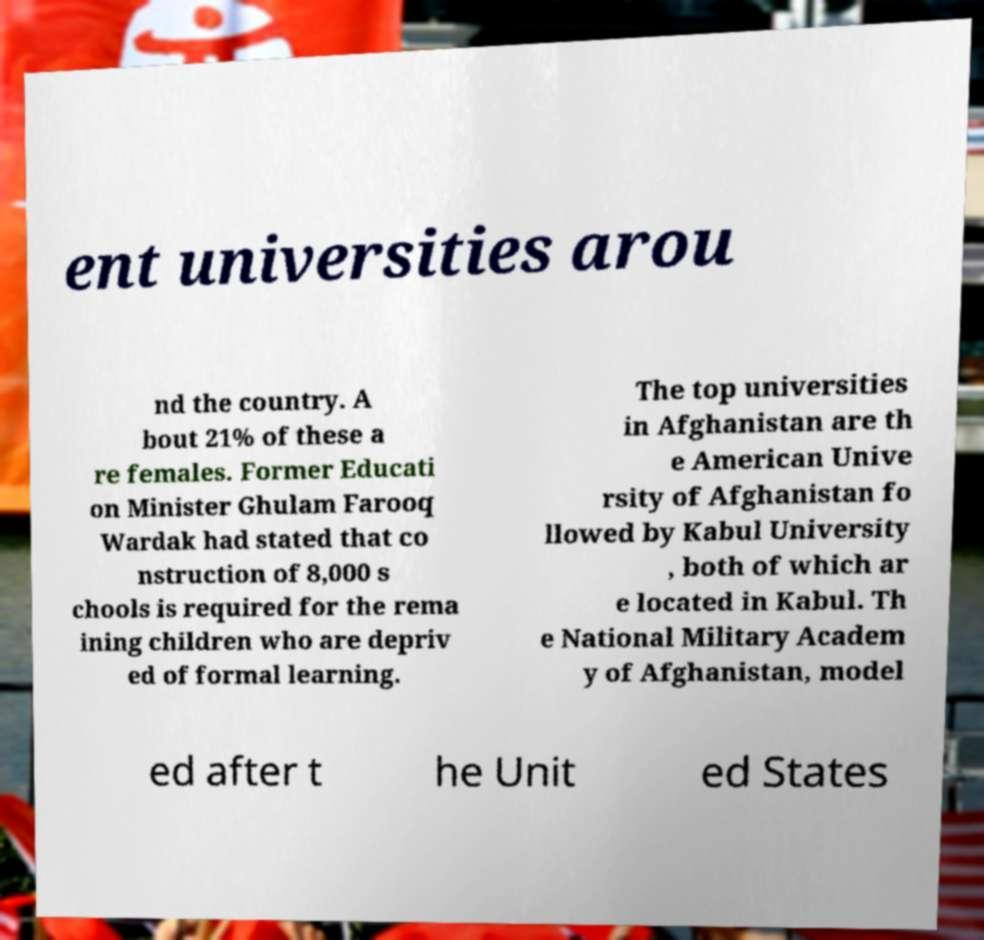For documentation purposes, I need the text within this image transcribed. Could you provide that? ent universities arou nd the country. A bout 21% of these a re females. Former Educati on Minister Ghulam Farooq Wardak had stated that co nstruction of 8,000 s chools is required for the rema ining children who are depriv ed of formal learning. The top universities in Afghanistan are th e American Unive rsity of Afghanistan fo llowed by Kabul University , both of which ar e located in Kabul. Th e National Military Academ y of Afghanistan, model ed after t he Unit ed States 